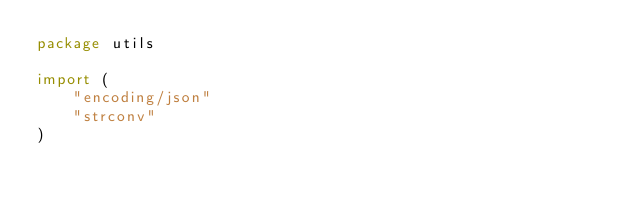<code> <loc_0><loc_0><loc_500><loc_500><_Go_>package utils

import (
	"encoding/json"
	"strconv"
)
</code> 